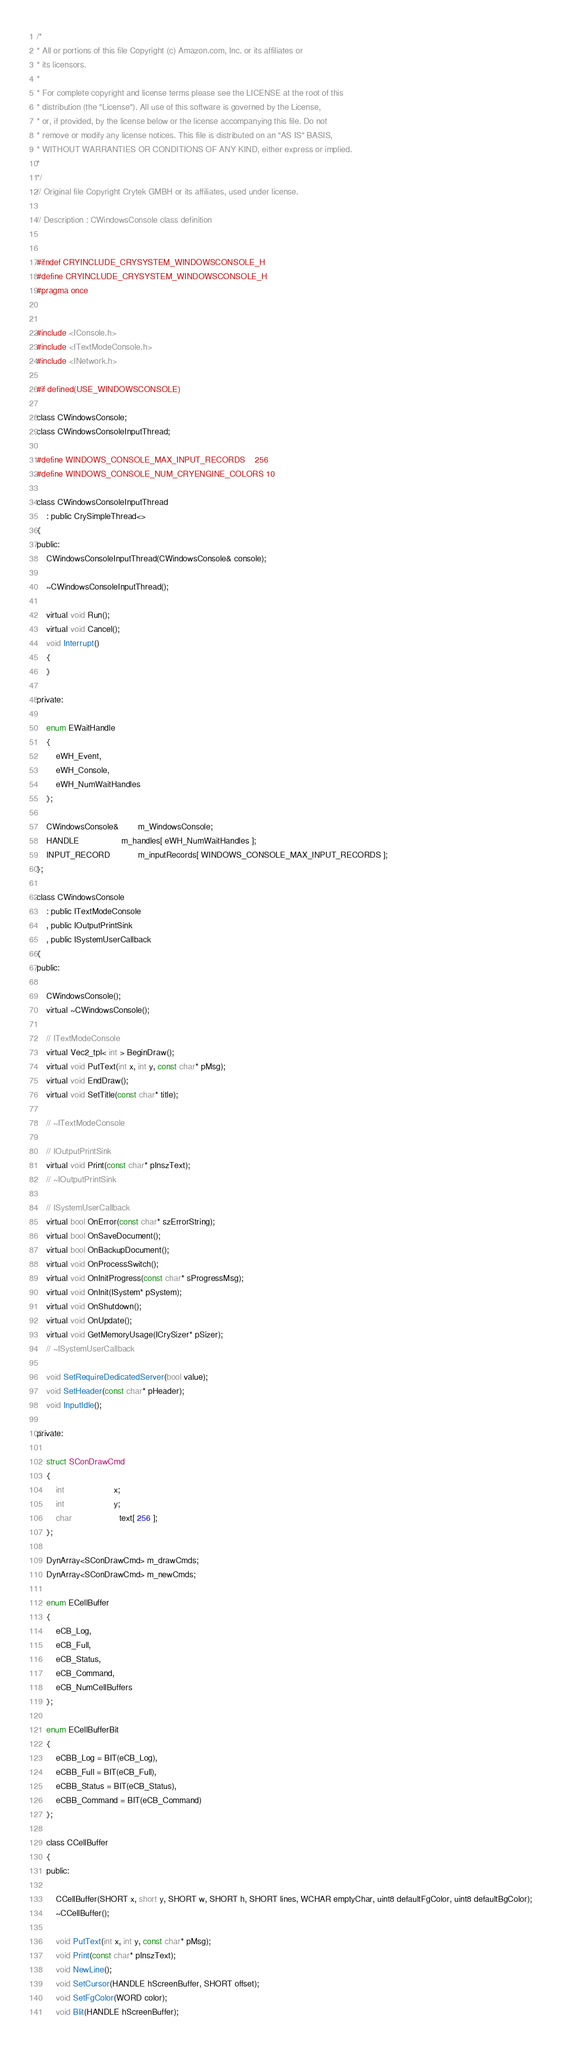<code> <loc_0><loc_0><loc_500><loc_500><_C_>/*
* All or portions of this file Copyright (c) Amazon.com, Inc. or its affiliates or
* its licensors.
*
* For complete copyright and license terms please see the LICENSE at the root of this
* distribution (the "License"). All use of this software is governed by the License,
* or, if provided, by the license below or the license accompanying this file. Do not
* remove or modify any license notices. This file is distributed on an "AS IS" BASIS,
* WITHOUT WARRANTIES OR CONDITIONS OF ANY KIND, either express or implied.
*
*/
// Original file Copyright Crytek GMBH or its affiliates, used under license.

// Description : CWindowsConsole class definition


#ifndef CRYINCLUDE_CRYSYSTEM_WINDOWSCONSOLE_H
#define CRYINCLUDE_CRYSYSTEM_WINDOWSCONSOLE_H
#pragma once


#include <IConsole.h>
#include <ITextModeConsole.h>
#include <INetwork.h>

#if defined(USE_WINDOWSCONSOLE)

class CWindowsConsole;
class CWindowsConsoleInputThread;

#define WINDOWS_CONSOLE_MAX_INPUT_RECORDS    256
#define WINDOWS_CONSOLE_NUM_CRYENGINE_COLORS 10

class CWindowsConsoleInputThread
    : public CrySimpleThread<>
{
public:
    CWindowsConsoleInputThread(CWindowsConsole& console);

    ~CWindowsConsoleInputThread();

    virtual void Run();
    virtual void Cancel();
    void Interrupt()
    {
    }

private:

    enum EWaitHandle
    {
        eWH_Event,
        eWH_Console,
        eWH_NumWaitHandles
    };

    CWindowsConsole&        m_WindowsConsole;
    HANDLE                  m_handles[ eWH_NumWaitHandles ];
    INPUT_RECORD            m_inputRecords[ WINDOWS_CONSOLE_MAX_INPUT_RECORDS ];
};

class CWindowsConsole
    : public ITextModeConsole
    , public IOutputPrintSink
    , public ISystemUserCallback
{
public:

    CWindowsConsole();
    virtual ~CWindowsConsole();

    // ITextModeConsole
    virtual Vec2_tpl< int > BeginDraw();
    virtual void PutText(int x, int y, const char* pMsg);
    virtual void EndDraw();
    virtual void SetTitle(const char* title);

    // ~ITextModeConsole

    // IOutputPrintSink
    virtual void Print(const char* pInszText);
    // ~IOutputPrintSink

    // ISystemUserCallback
    virtual bool OnError(const char* szErrorString);
    virtual bool OnSaveDocument();
    virtual bool OnBackupDocument();
    virtual void OnProcessSwitch();
    virtual void OnInitProgress(const char* sProgressMsg);
    virtual void OnInit(ISystem* pSystem);
    virtual void OnShutdown();
    virtual void OnUpdate();
    virtual void GetMemoryUsage(ICrySizer* pSizer);
    // ~ISystemUserCallback

    void SetRequireDedicatedServer(bool value);
    void SetHeader(const char* pHeader);
    void InputIdle();

private:

    struct SConDrawCmd
    {
        int                     x;
        int                     y;
        char                    text[ 256 ];
    };

    DynArray<SConDrawCmd> m_drawCmds;
    DynArray<SConDrawCmd> m_newCmds;

    enum ECellBuffer
    {
        eCB_Log,
        eCB_Full,
        eCB_Status,
        eCB_Command,
        eCB_NumCellBuffers
    };

    enum ECellBufferBit
    {
        eCBB_Log = BIT(eCB_Log),
        eCBB_Full = BIT(eCB_Full),
        eCBB_Status = BIT(eCB_Status),
        eCBB_Command = BIT(eCB_Command)
    };

    class CCellBuffer
    {
    public:

        CCellBuffer(SHORT x, short y, SHORT w, SHORT h, SHORT lines, WCHAR emptyChar, uint8 defaultFgColor, uint8 defaultBgColor);
        ~CCellBuffer();

        void PutText(int x, int y, const char* pMsg);
        void Print(const char* pInszText);
        void NewLine();
        void SetCursor(HANDLE hScreenBuffer, SHORT offset);
        void SetFgColor(WORD color);
        void Blit(HANDLE hScreenBuffer);</code> 